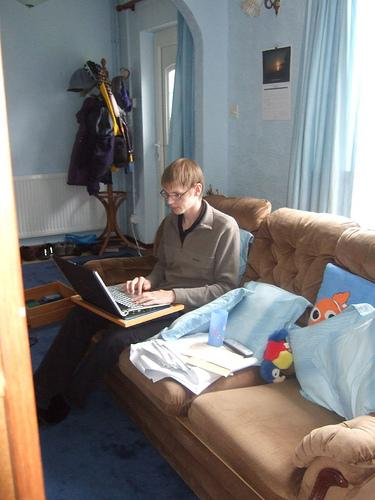The fish on the pillow goes by what name?

Choices:
A) finbar
B) dory
C) nemo
D) flounder nemo 